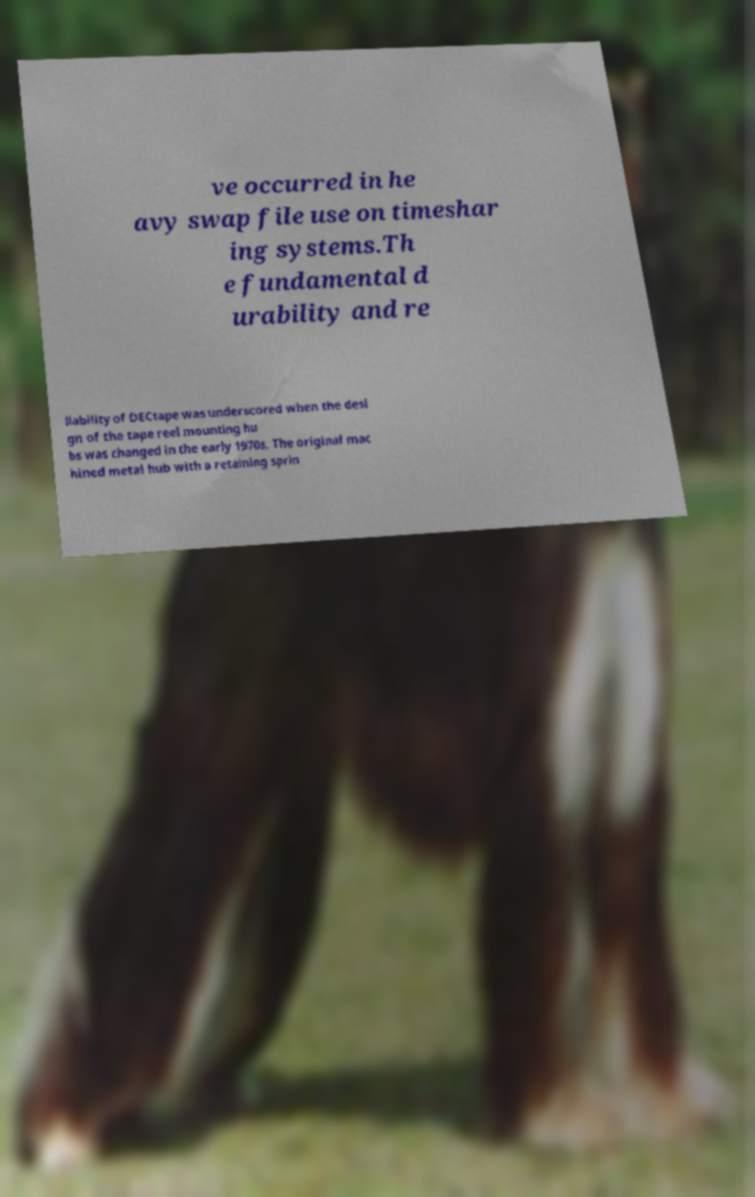Can you read and provide the text displayed in the image?This photo seems to have some interesting text. Can you extract and type it out for me? ve occurred in he avy swap file use on timeshar ing systems.Th e fundamental d urability and re liability of DECtape was underscored when the desi gn of the tape reel mounting hu bs was changed in the early 1970s. The original mac hined metal hub with a retaining sprin 